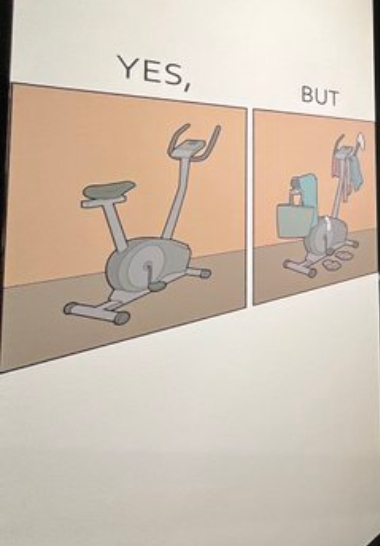Provide a description of this image. The image is funny because while the intention of getting a cycling exercise machine is to do workout, it is being used for hanging clothes and other things on it. 